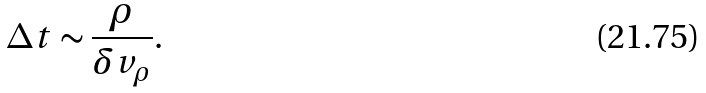<formula> <loc_0><loc_0><loc_500><loc_500>\Delta t \sim \frac { \rho } { \delta v _ { \rho } } .</formula> 